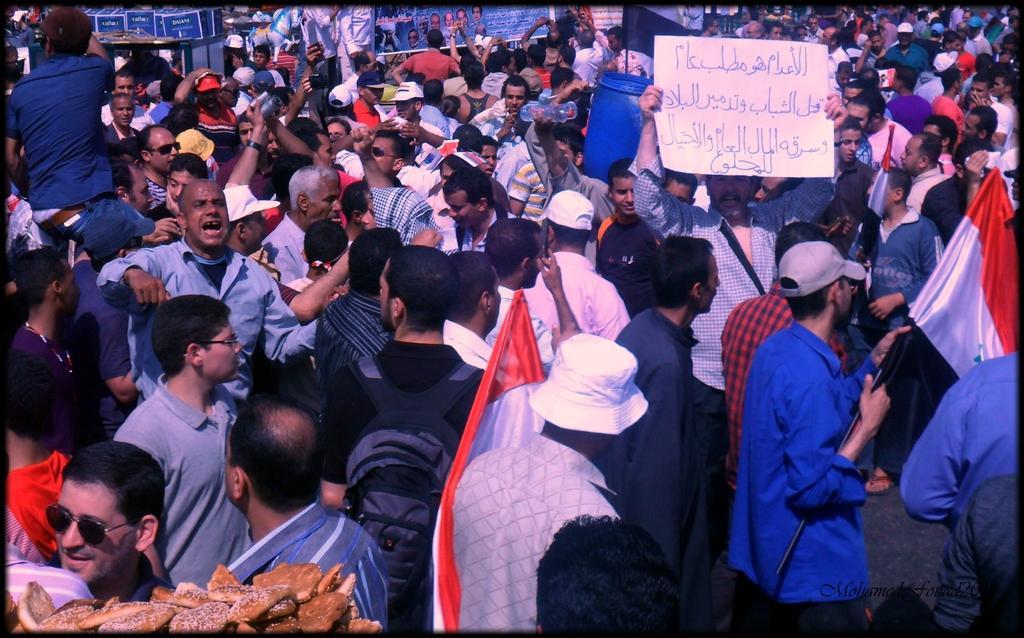In one or two sentences, can you explain what this image depicts? In this image I can see number of people are standing and in the front I can see two of them are holding flags. I can also see one person is holding a board on the right side and on the bottom left side of this image I can see number of brown colour things. On the top left side of this image I can see number of boards, banners and on it I can see something is written. 